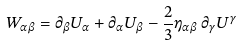Convert formula to latex. <formula><loc_0><loc_0><loc_500><loc_500>W _ { \alpha \beta } = \partial _ { \beta } U _ { \alpha } + \partial _ { \alpha } U _ { \beta } - \frac { 2 } { 3 } \eta _ { \alpha \beta } \, \partial _ { \gamma } U ^ { \gamma }</formula> 